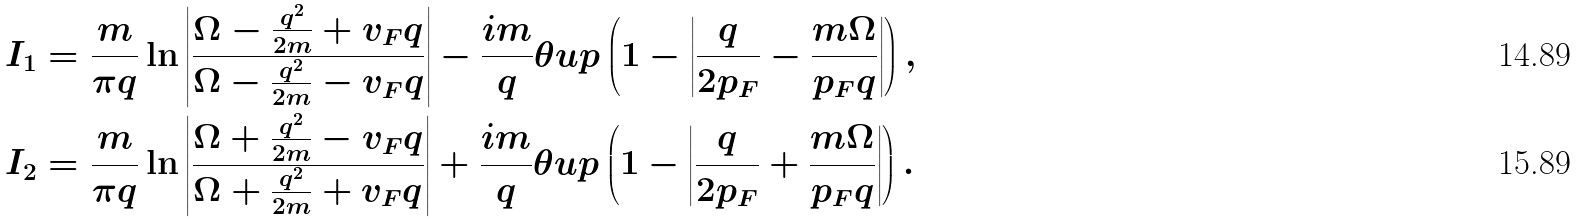Convert formula to latex. <formula><loc_0><loc_0><loc_500><loc_500>I _ { 1 } & = \frac { m } { \pi q } \ln \left | \frac { \Omega - \frac { q ^ { 2 } } { 2 m } + v _ { F } q } { \Omega - \frac { q ^ { 2 } } { 2 m } - v _ { F } q } \right | - \frac { i m } { q } \theta u p \left ( 1 - \left | \frac { q } { 2 p _ { F } } - \frac { m \Omega } { p _ { F } q } \right | \right ) , \\ I _ { 2 } & = \frac { m } { \pi q } \ln \left | \frac { \Omega + \frac { q ^ { 2 } } { 2 m } - v _ { F } q } { \Omega + \frac { q ^ { 2 } } { 2 m } + v _ { F } q } \right | + \frac { i m } { q } \theta u p \left ( 1 - \left | \frac { q } { 2 p _ { F } } + \frac { m \Omega } { p _ { F } q } \right | \right ) .</formula> 